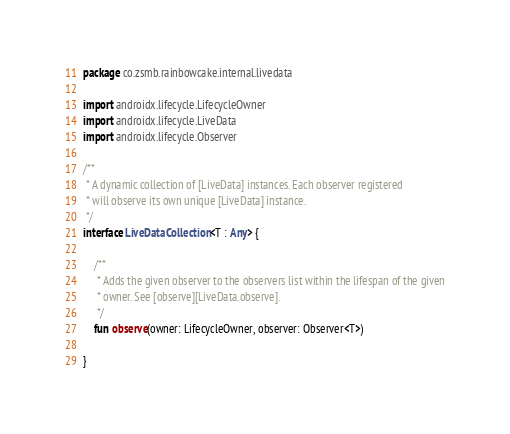<code> <loc_0><loc_0><loc_500><loc_500><_Kotlin_>package co.zsmb.rainbowcake.internal.livedata

import androidx.lifecycle.LifecycleOwner
import androidx.lifecycle.LiveData
import androidx.lifecycle.Observer

/**
 * A dynamic collection of [LiveData] instances. Each observer registered
 * will observe its own unique [LiveData] instance.
 */
interface LiveDataCollection<T : Any> {

    /**
     * Adds the given observer to the observers list within the lifespan of the given
     * owner. See [observe][LiveData.observe].
     */
    fun observe(owner: LifecycleOwner, observer: Observer<T>)

}
</code> 